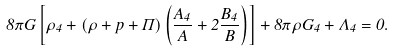Convert formula to latex. <formula><loc_0><loc_0><loc_500><loc_500>8 \pi G \left [ \rho _ { 4 } + ( \rho + p + \Pi ) \left ( \frac { A _ { 4 } } { A } + 2 \frac { B _ { 4 } } { B } \right ) \right ] + 8 \pi \rho G _ { 4 } + \Lambda _ { 4 } = 0 .</formula> 